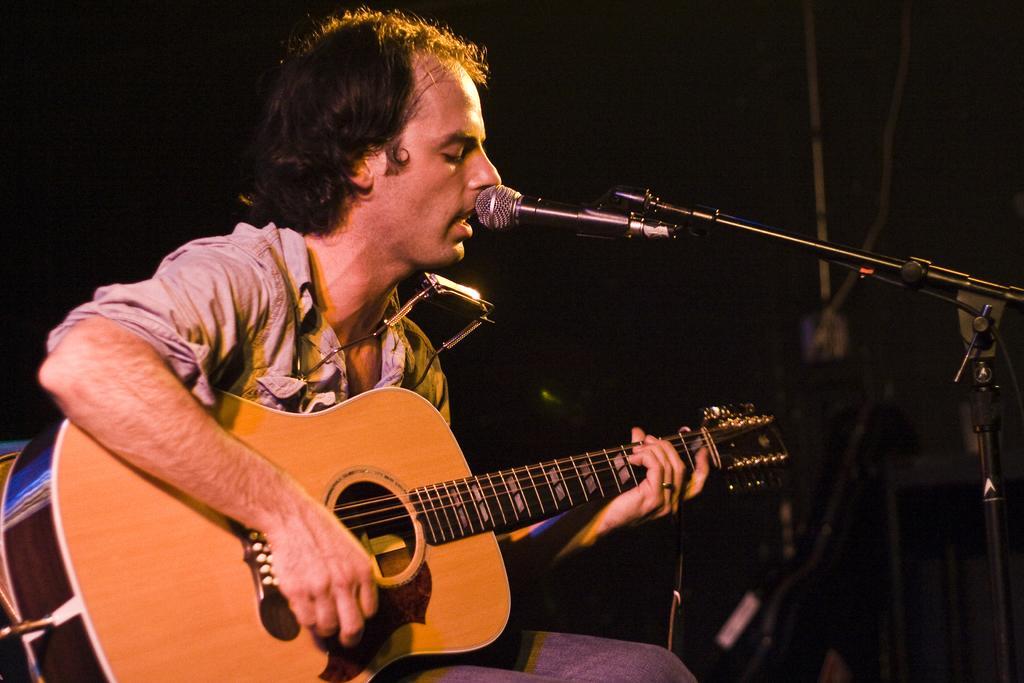Please provide a concise description of this image. In this image there is a person wearing brown color shirt playing guitar in front of him there is a microphone. 